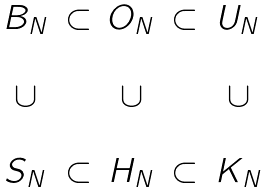<formula> <loc_0><loc_0><loc_500><loc_500>\begin{matrix} B _ { N } & \subset & O _ { N } & \subset & U _ { N } \\ \\ \cup & & \cup & & \cup \\ \\ S _ { N } & \subset & H _ { N } & \subset & K _ { N } \end{matrix}</formula> 